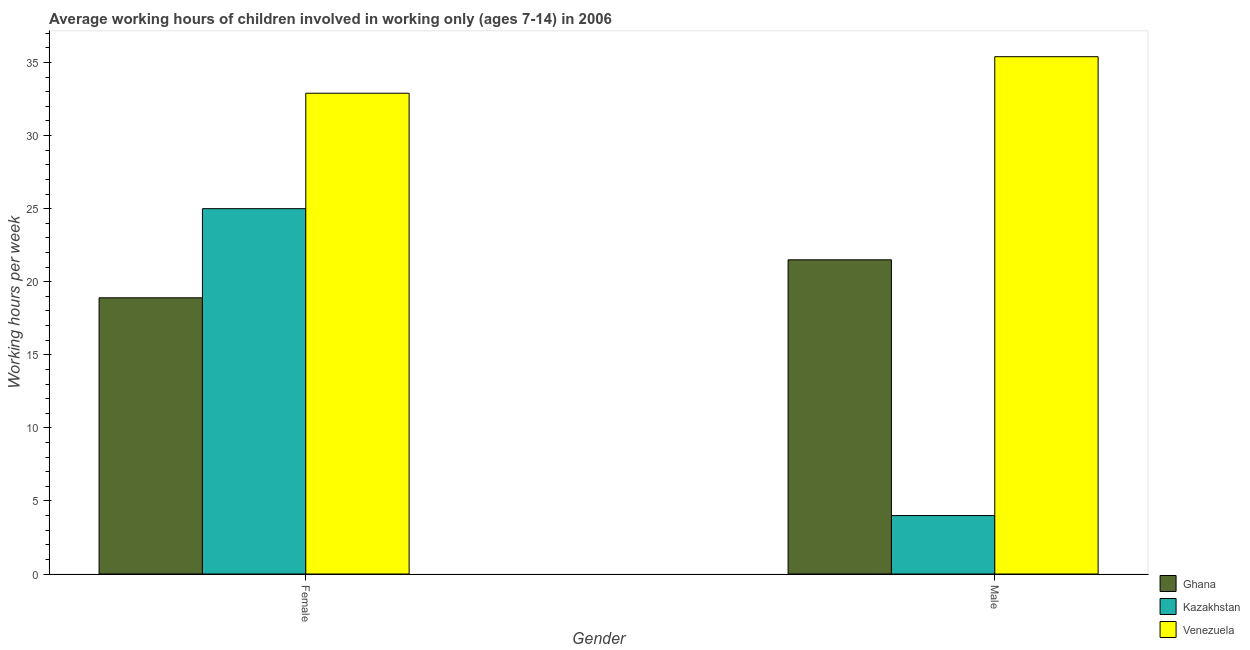How many bars are there on the 2nd tick from the right?
Your answer should be very brief. 3. What is the average working hour of female children in Venezuela?
Your answer should be very brief. 32.9. Across all countries, what is the maximum average working hour of female children?
Make the answer very short. 32.9. Across all countries, what is the minimum average working hour of female children?
Provide a succinct answer. 18.9. In which country was the average working hour of male children maximum?
Provide a short and direct response. Venezuela. In which country was the average working hour of male children minimum?
Keep it short and to the point. Kazakhstan. What is the total average working hour of female children in the graph?
Offer a terse response. 76.8. What is the difference between the average working hour of female children in Kazakhstan and that in Ghana?
Make the answer very short. 6.1. What is the difference between the average working hour of female children in Ghana and the average working hour of male children in Kazakhstan?
Ensure brevity in your answer.  14.9. What is the average average working hour of female children per country?
Give a very brief answer. 25.6. What is the difference between the average working hour of female children and average working hour of male children in Ghana?
Your answer should be very brief. -2.6. In how many countries, is the average working hour of male children greater than 8 hours?
Offer a terse response. 2. What is the ratio of the average working hour of male children in Kazakhstan to that in Venezuela?
Offer a very short reply. 0.11. Is the average working hour of male children in Ghana less than that in Venezuela?
Provide a succinct answer. Yes. What does the 3rd bar from the left in Male represents?
Offer a terse response. Venezuela. How many bars are there?
Give a very brief answer. 6. How many countries are there in the graph?
Offer a terse response. 3. What is the difference between two consecutive major ticks on the Y-axis?
Provide a succinct answer. 5. Does the graph contain any zero values?
Give a very brief answer. No. Does the graph contain grids?
Provide a short and direct response. No. What is the title of the graph?
Keep it short and to the point. Average working hours of children involved in working only (ages 7-14) in 2006. Does "Samoa" appear as one of the legend labels in the graph?
Give a very brief answer. No. What is the label or title of the X-axis?
Ensure brevity in your answer.  Gender. What is the label or title of the Y-axis?
Your response must be concise. Working hours per week. What is the Working hours per week of Venezuela in Female?
Make the answer very short. 32.9. What is the Working hours per week in Kazakhstan in Male?
Provide a succinct answer. 4. What is the Working hours per week of Venezuela in Male?
Ensure brevity in your answer.  35.4. Across all Gender, what is the maximum Working hours per week in Ghana?
Your response must be concise. 21.5. Across all Gender, what is the maximum Working hours per week of Kazakhstan?
Make the answer very short. 25. Across all Gender, what is the maximum Working hours per week of Venezuela?
Make the answer very short. 35.4. Across all Gender, what is the minimum Working hours per week in Venezuela?
Give a very brief answer. 32.9. What is the total Working hours per week of Ghana in the graph?
Offer a terse response. 40.4. What is the total Working hours per week in Venezuela in the graph?
Offer a very short reply. 68.3. What is the difference between the Working hours per week in Kazakhstan in Female and that in Male?
Make the answer very short. 21. What is the difference between the Working hours per week in Venezuela in Female and that in Male?
Make the answer very short. -2.5. What is the difference between the Working hours per week of Ghana in Female and the Working hours per week of Kazakhstan in Male?
Your answer should be compact. 14.9. What is the difference between the Working hours per week of Ghana in Female and the Working hours per week of Venezuela in Male?
Keep it short and to the point. -16.5. What is the difference between the Working hours per week in Kazakhstan in Female and the Working hours per week in Venezuela in Male?
Offer a terse response. -10.4. What is the average Working hours per week in Ghana per Gender?
Your answer should be very brief. 20.2. What is the average Working hours per week in Venezuela per Gender?
Keep it short and to the point. 34.15. What is the difference between the Working hours per week of Ghana and Working hours per week of Venezuela in Male?
Provide a short and direct response. -13.9. What is the difference between the Working hours per week in Kazakhstan and Working hours per week in Venezuela in Male?
Provide a short and direct response. -31.4. What is the ratio of the Working hours per week of Ghana in Female to that in Male?
Give a very brief answer. 0.88. What is the ratio of the Working hours per week of Kazakhstan in Female to that in Male?
Ensure brevity in your answer.  6.25. What is the ratio of the Working hours per week in Venezuela in Female to that in Male?
Give a very brief answer. 0.93. What is the difference between the highest and the second highest Working hours per week in Ghana?
Provide a succinct answer. 2.6. What is the difference between the highest and the second highest Working hours per week of Venezuela?
Make the answer very short. 2.5. What is the difference between the highest and the lowest Working hours per week of Ghana?
Offer a very short reply. 2.6. What is the difference between the highest and the lowest Working hours per week of Venezuela?
Offer a terse response. 2.5. 